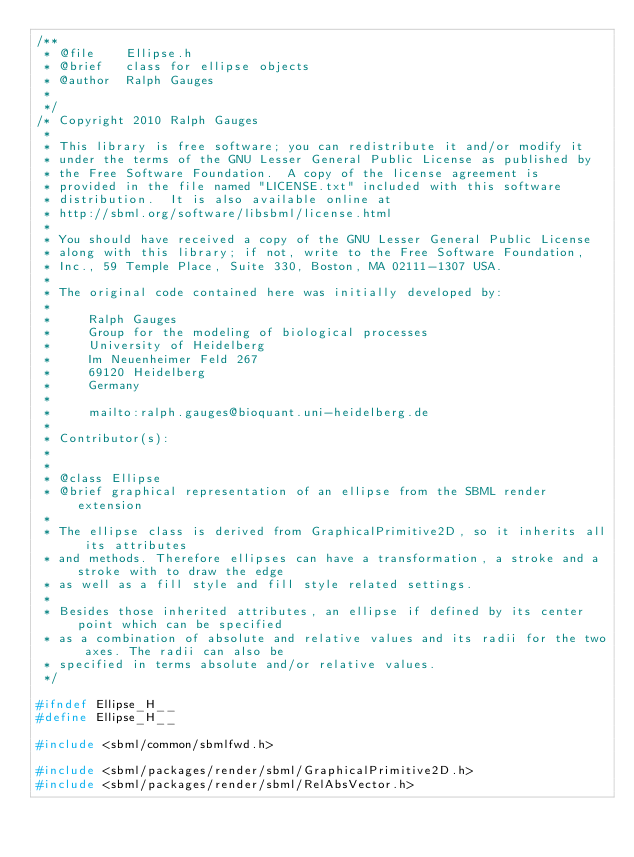<code> <loc_0><loc_0><loc_500><loc_500><_C_>/**
 * @file    Ellipse.h
 * @brief   class for ellipse objects
 * @author  Ralph Gauges
 *
 */
/* Copyright 2010 Ralph Gauges
 *
 * This library is free software; you can redistribute it and/or modify it
 * under the terms of the GNU Lesser General Public License as published by
 * the Free Software Foundation.  A copy of the license agreement is
 * provided in the file named "LICENSE.txt" included with this software
 * distribution.  It is also available online at
 * http://sbml.org/software/libsbml/license.html
 *
 * You should have received a copy of the GNU Lesser General Public License
 * along with this library; if not, write to the Free Software Foundation,
 * Inc., 59 Temple Place, Suite 330, Boston, MA 02111-1307 USA.
 *
 * The original code contained here was initially developed by:
 *
 *     Ralph Gauges
 *     Group for the modeling of biological processes 
 *     University of Heidelberg
 *     Im Neuenheimer Feld 267
 *     69120 Heidelberg
 *     Germany
 *
 *     mailto:ralph.gauges@bioquant.uni-heidelberg.de
 *
 * Contributor(s):
 *
 *
 * @class Ellipse
 * @brief graphical representation of an ellipse from the SBML render extension
 *
 * The ellipse class is derived from GraphicalPrimitive2D, so it inherits all its attributes
 * and methods. Therefore ellipses can have a transformation, a stroke and a stroke with to draw the edge
 * as well as a fill style and fill style related settings.
 *
 * Besides those inherited attributes, an ellipse if defined by its center point which can be specified 
 * as a combination of absolute and relative values and its radii for the two axes. The radii can also be
 * specified in terms absolute and/or relative values.
 */

#ifndef Ellipse_H__
#define Ellipse_H__

#include <sbml/common/sbmlfwd.h>

#include <sbml/packages/render/sbml/GraphicalPrimitive2D.h>
#include <sbml/packages/render/sbml/RelAbsVector.h></code> 